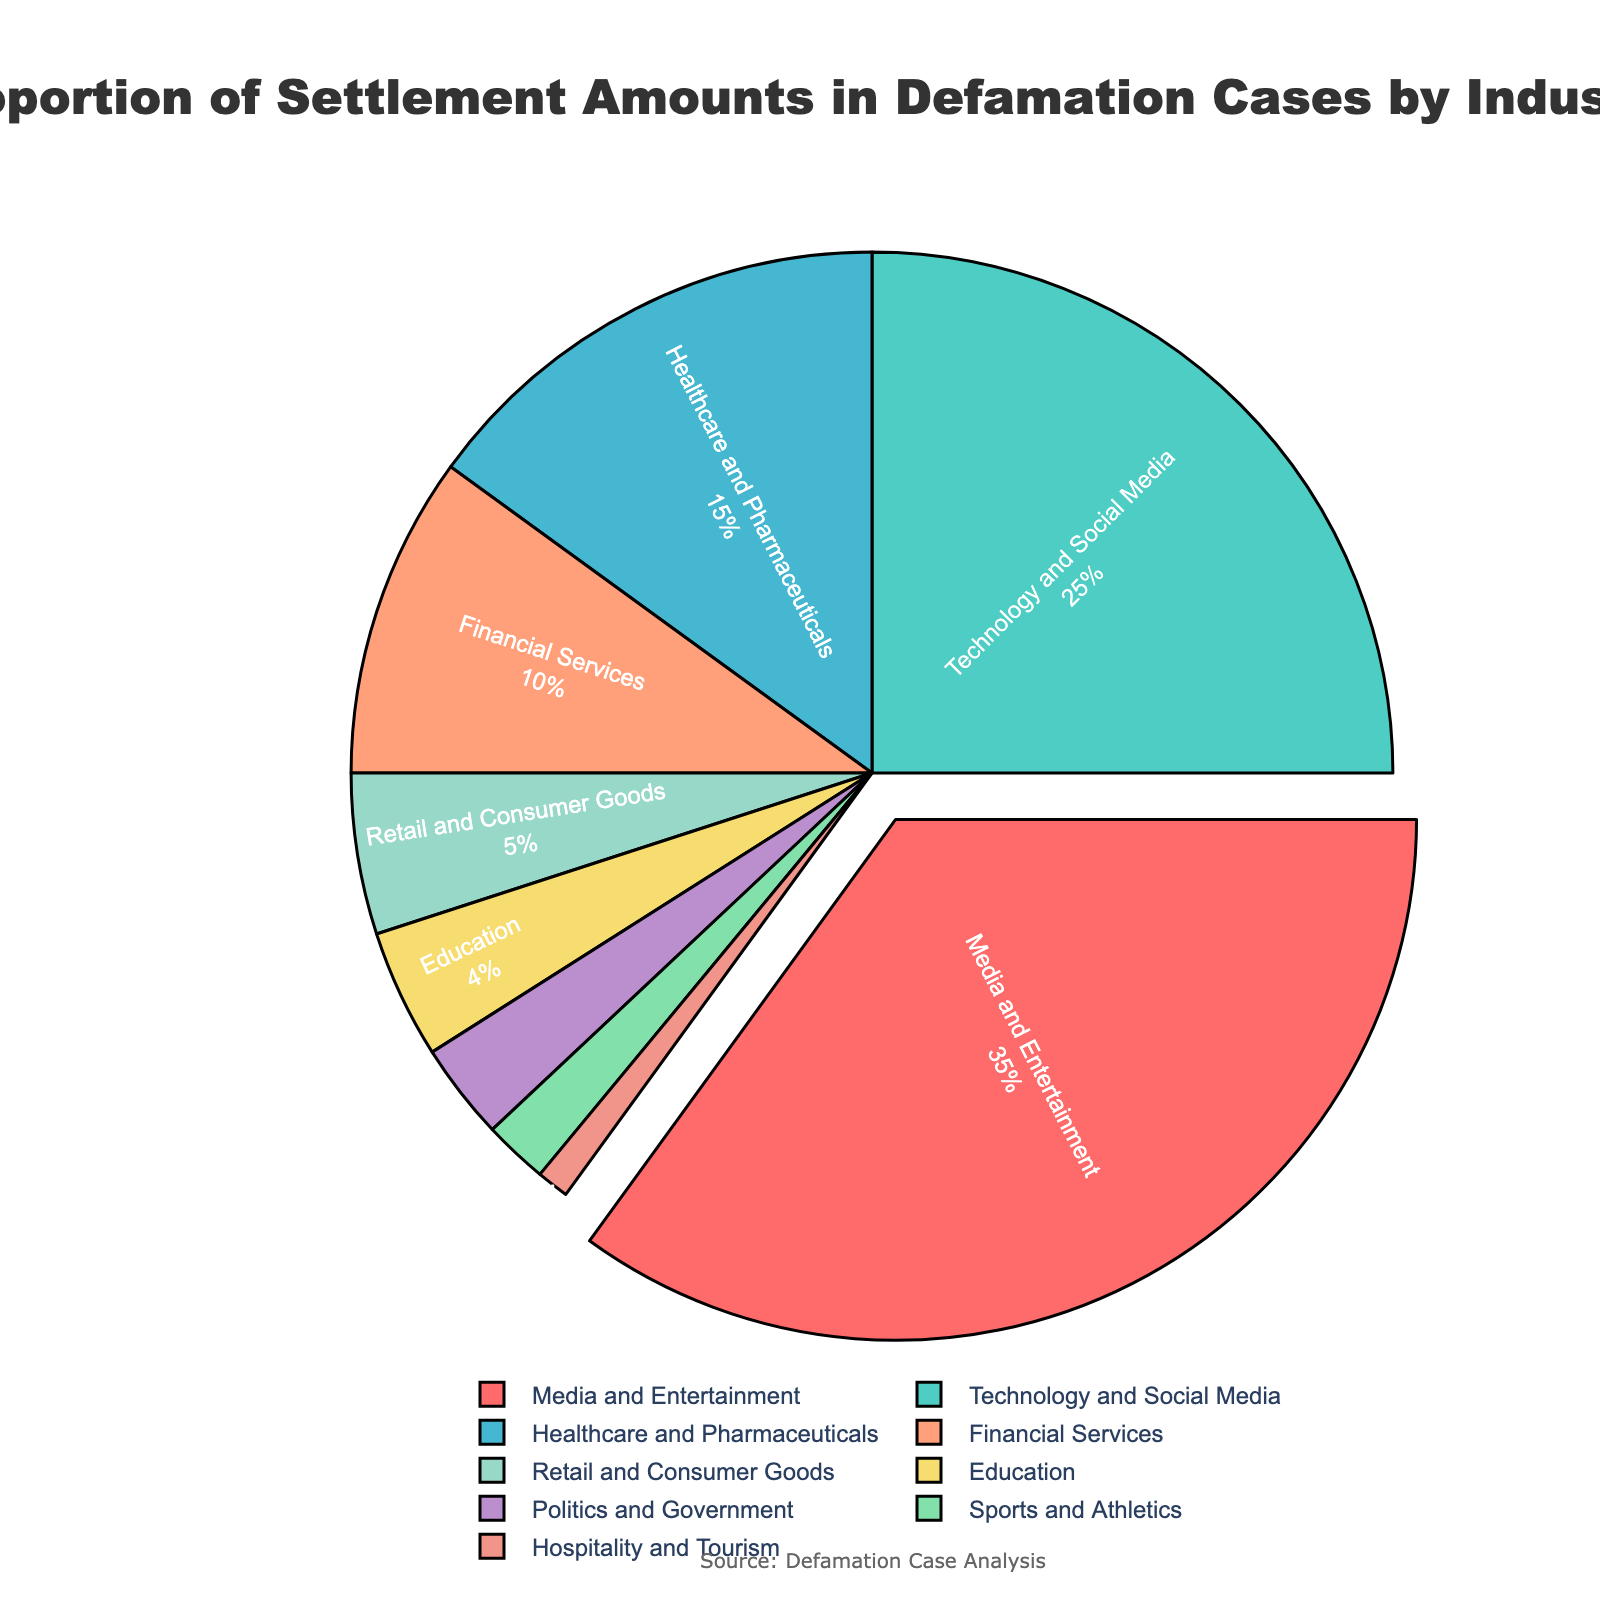What proportion of settlement amounts in defamation cases does the entertainment industry hold? The entertainment industry's label shows both the industry name and its corresponding percentage.
Answer: 35% Which industry has the second-highest share of settlement amounts? By comparing the proportions, the second-largest slice, after Media and Entertainment, is for Technology and Social Media.
Answer: Technology and Social Media What is the combined proportion of settlement amounts for Healthcare and Pharmaceuticals and Financial Services? Summing the specific proportions of these two industries: 15% + 10%.
Answer: 25% Is the proportion for Retail and Consumer Goods higher or lower than Education? Comparing the two proportions: Retail and Consumer Goods (5%) and Education (4%).
Answer: Higher What is the total proportion of settlement amounts held by the bottom three industries? Summing the proportions of the bottom three industries: Education (4%), Politics and Government (3%), and Sports and Athletics (2%).
Answer: 9% Which color represents the Hospitality and Tourism industry in the pie chart? Observe the smallest segment in the figure where Hospitality and Tourism is labeled. The associated color is noted.
Answer: Light pink By how much does the proportion of the Technology and Social Media industry exceed that of Sports and Athletics? Subtracting the target proportions: 25% for Technology and Social Media minus 2% for Sports and Athletics.
Answer: 23% How does the proportion of the Media and Entertainment industry compare to all other industries combined? The total proportion of Media and Entertainment is 35%. Comparing it with the sum of the rest (100% - 35%).
Answer: Lower What is the median proportion of settlement amounts amongst all the industries? Listing the proportions in ascending order (0.01, 0.02, 0.03, 0.04, 0.05, 0.10, 0.15, 0.25, 0.35), the middle value in this order is found as 0.05.
Answer: 5% Which industries together form more than 50% of the total settlement amounts? Continuously adding the highest proportions until the sum exceeds half: Media and Entertainment (35%) + Technology and Social Media (25%). The rest are not necessary.
Answer: Media and Entertainment and Technology and Social Media 